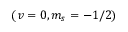<formula> <loc_0><loc_0><loc_500><loc_500>( v = 0 , m _ { s } = - 1 / 2 )</formula> 